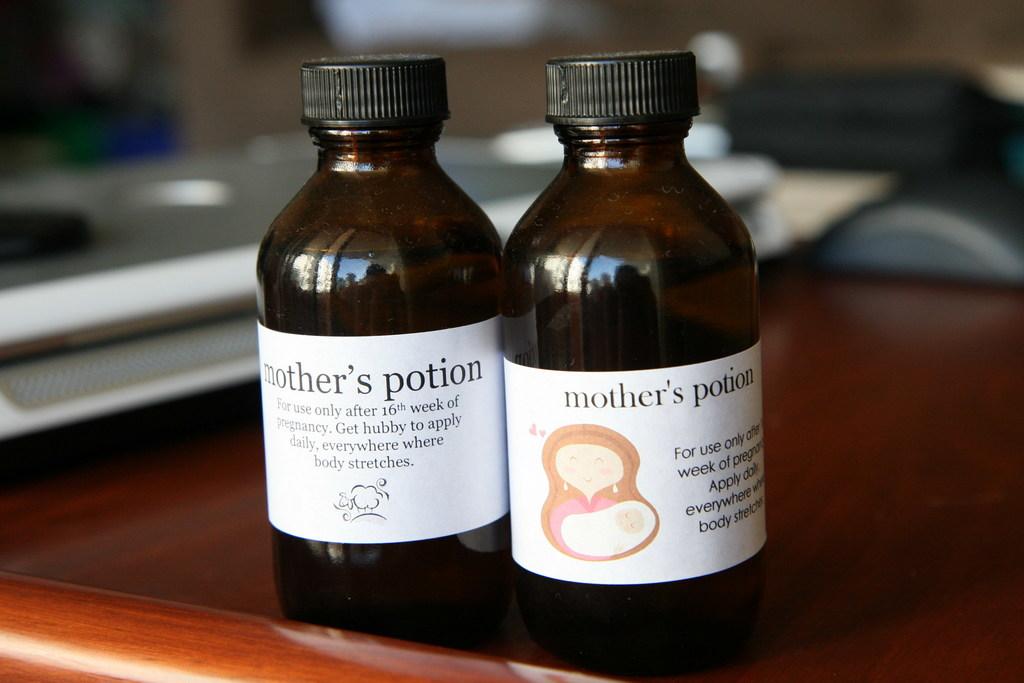Is this mother's potion?
Make the answer very short. Yes. 